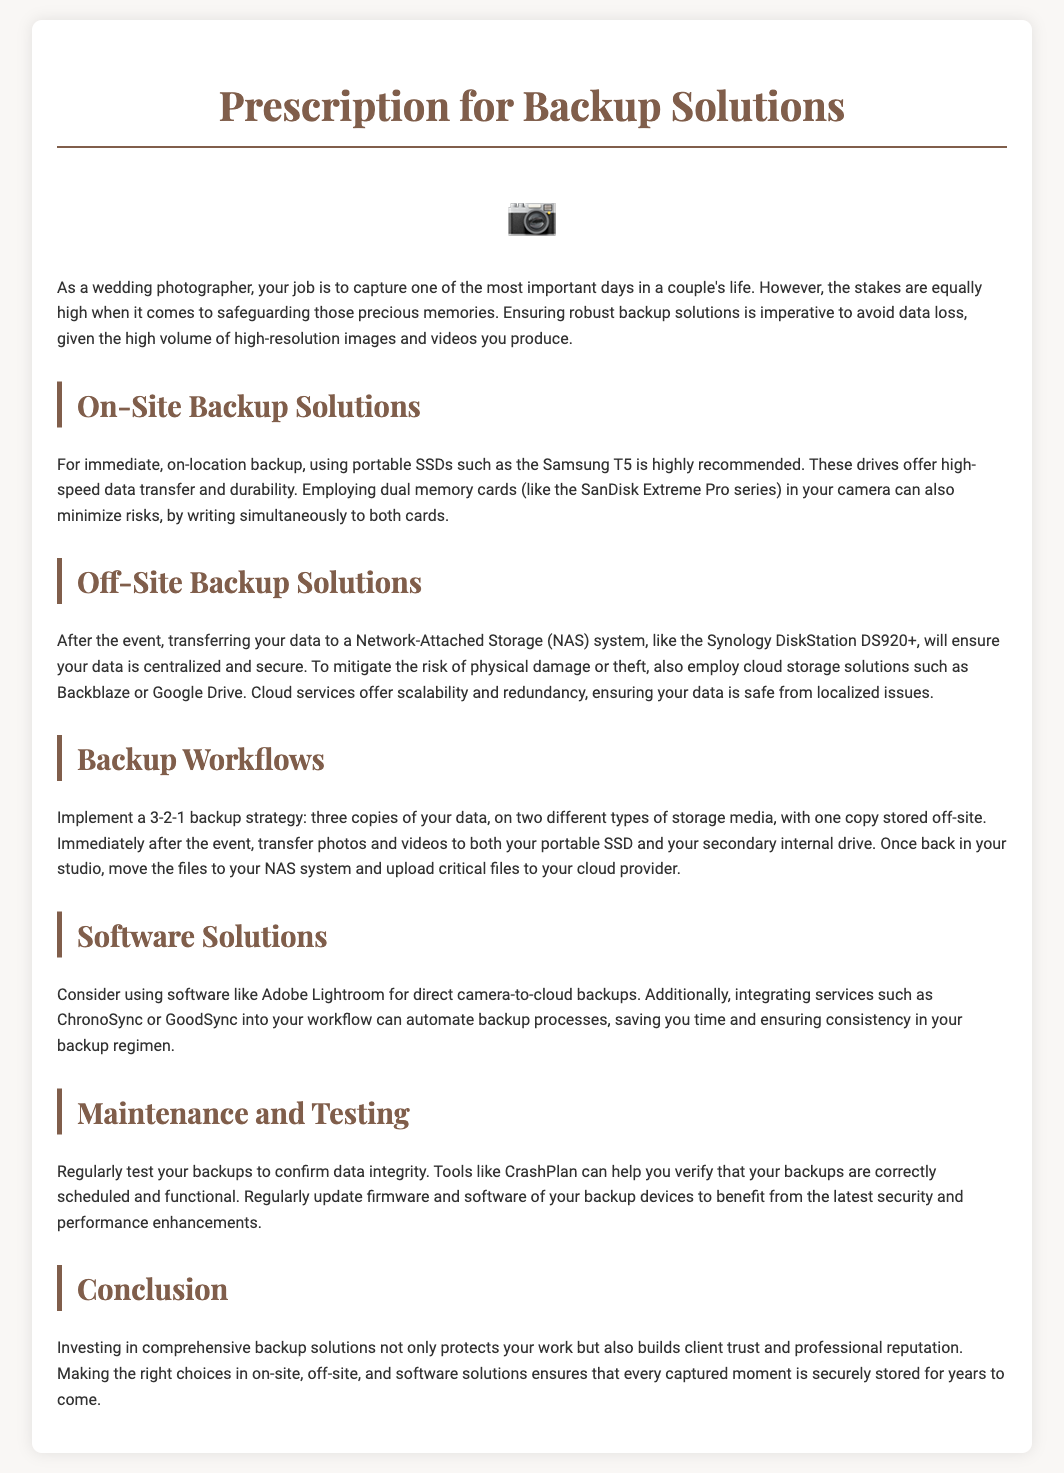What is the recommended portable SSD? The document recommends using the Samsung T5 for on-site backup solutions.
Answer: Samsung T5 What is the purpose of dual memory cards? Dual memory cards minimize risks by writing simultaneously to both cards, providing a backup while capturing.
Answer: Minimize risks What is the 3-2-1 backup strategy? The 3-2-1 backup strategy involves three copies of data on two different types of storage media, with one copy stored off-site.
Answer: Three copies Which cloud storage services are mentioned? The document mentions Backblaze and Google Drive as cloud storage solutions for off-site data security.
Answer: Backblaze, Google Drive What is an important software for direct camera-to-cloud backups? Adobe Lightroom is highlighted as a software solution for direct camera-to-cloud backups.
Answer: Adobe Lightroom What should you regularly test to confirm data integrity? Regularly testing the backups is needed to ensure data integrity.
Answer: Backups What device is suggested for centralized data storage? The Synology DiskStation DS920+ is recommended for centralized and secure data storage.
Answer: Synology DiskStation DS920+ What is the primary benefit of comprehensive backup solutions? Investing in comprehensive backup solutions protects work and builds client trust and professional reputation.
Answer: Client trust 